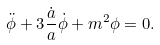<formula> <loc_0><loc_0><loc_500><loc_500>\ddot { \phi } + 3 \frac { \dot { a } } { a } \dot { \phi } + m ^ { 2 } \phi = 0 .</formula> 